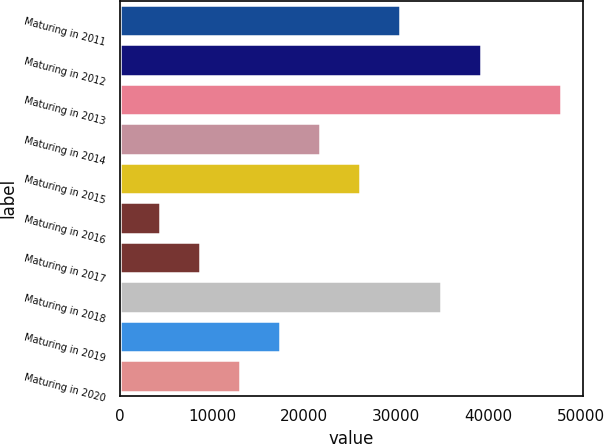Convert chart. <chart><loc_0><loc_0><loc_500><loc_500><bar_chart><fcel>Maturing in 2011<fcel>Maturing in 2012<fcel>Maturing in 2013<fcel>Maturing in 2014<fcel>Maturing in 2015<fcel>Maturing in 2016<fcel>Maturing in 2017<fcel>Maturing in 2018<fcel>Maturing in 2019<fcel>Maturing in 2020<nl><fcel>30460.5<fcel>39157.5<fcel>47854.5<fcel>21763.5<fcel>26112<fcel>4369.5<fcel>8718<fcel>34809<fcel>17415<fcel>13066.5<nl></chart> 